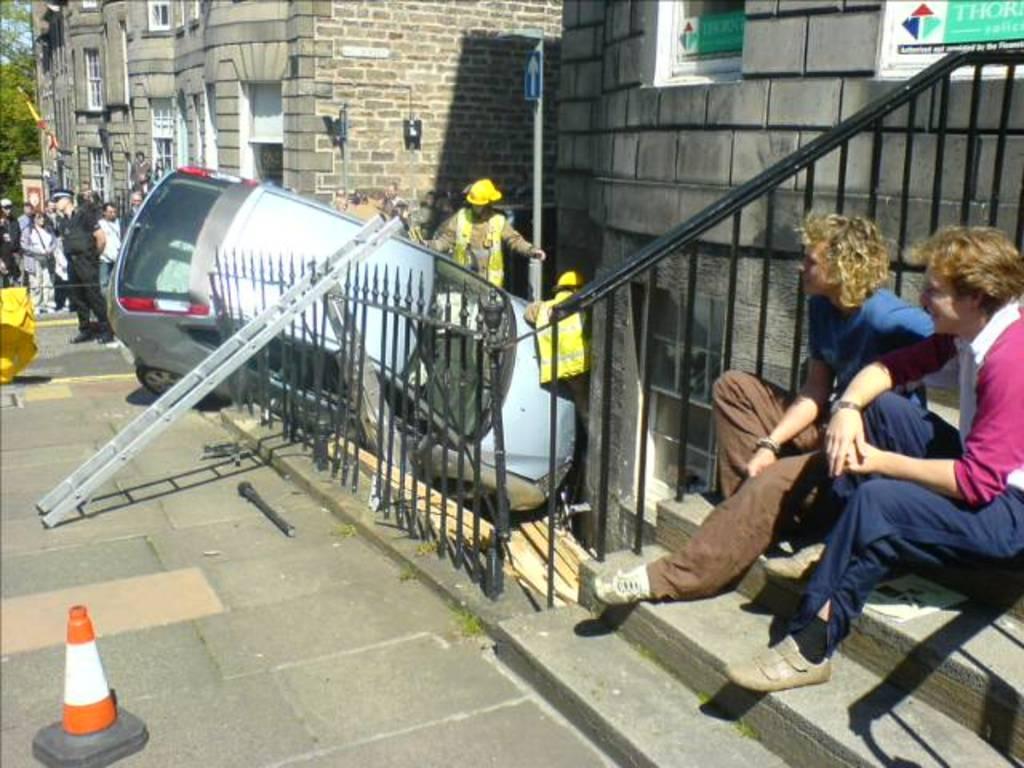In one or two sentences, can you explain what this image depicts? On the right there is a man who is sitting on the stairs. Beside him we can see another man who is wearing blue t-shirt and shoe. Here we can see two rescue persons who are standing near to the car. Here we can see ladder on the fencing. On the left we can see police man who is wearing black dress. Here we can see group of person standing near to the building. On the top left there is a flag. Here we can see many trees. Here it's a sky. On the bottom left corner there is a traffic cone. On the top right corner there is a board. Here we can see sign board near to the brick wall. 